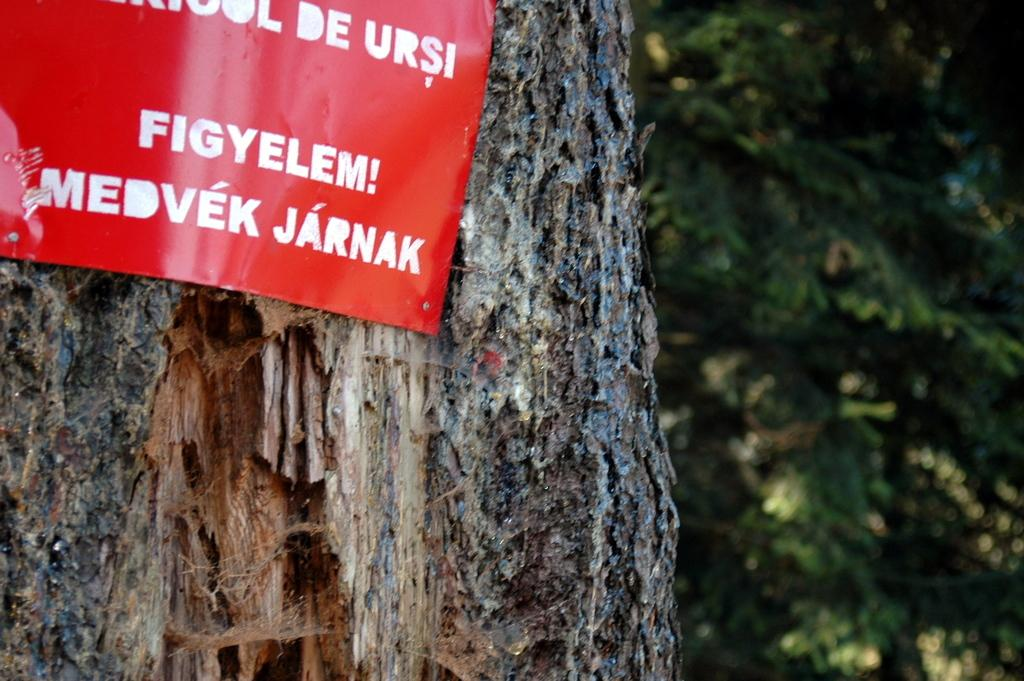What is attached to the tree in the image? There is a board with text in the image, and it is pinned on a tree. Can you describe the board in the image? The board has text on it. What type of object is visible in the image besides the board? There is a tree visible in the image. How much profit did the tree make in the image? There is no mention of profit in the image, as it features a board with text pinned on a tree. 